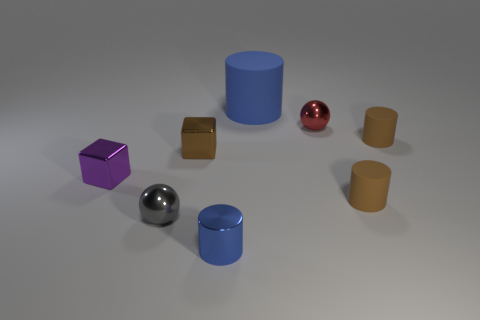Subtract 1 cylinders. How many cylinders are left? 3 Add 2 shiny cubes. How many objects exist? 10 Subtract all spheres. How many objects are left? 6 Add 1 large blue things. How many large blue things are left? 2 Add 1 big blue matte cylinders. How many big blue matte cylinders exist? 2 Subtract 1 brown cylinders. How many objects are left? 7 Subtract all tiny blue metal things. Subtract all big blue objects. How many objects are left? 6 